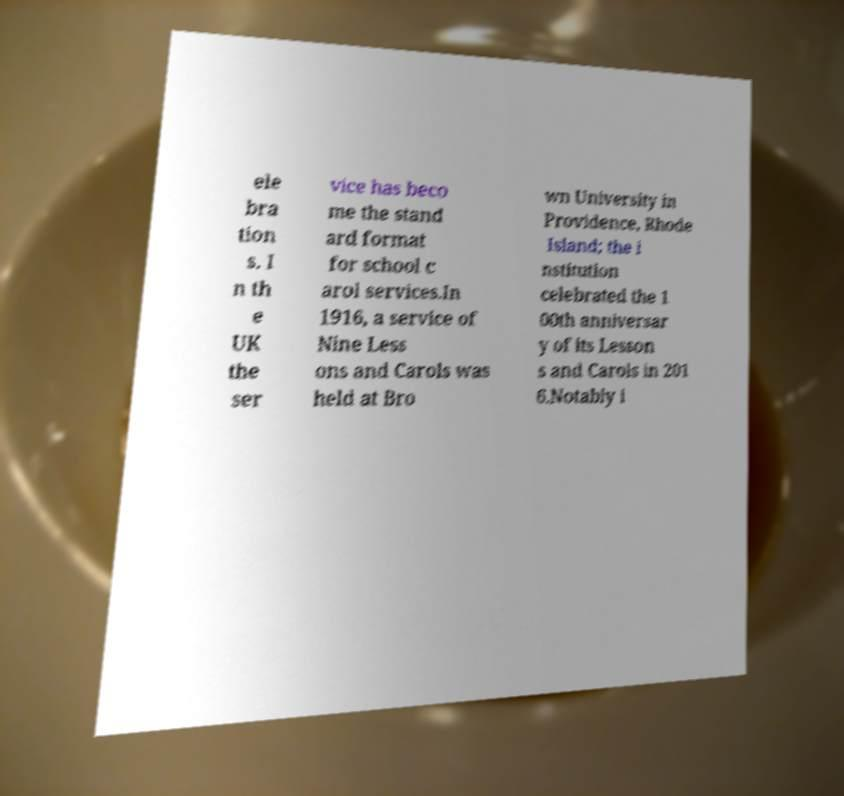Can you read and provide the text displayed in the image?This photo seems to have some interesting text. Can you extract and type it out for me? ele bra tion s. I n th e UK the ser vice has beco me the stand ard format for school c arol services.In 1916, a service of Nine Less ons and Carols was held at Bro wn University in Providence, Rhode Island; the i nstitution celebrated the 1 00th anniversar y of its Lesson s and Carols in 201 6.Notably i 